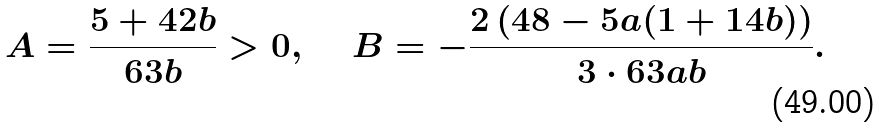Convert formula to latex. <formula><loc_0><loc_0><loc_500><loc_500>A & = \frac { 5 + 4 2 b } { 6 3 b } > 0 , & B & = - \frac { 2 \left ( 4 8 - 5 a ( 1 + 1 4 b ) \right ) } { 3 \cdot 6 3 a b } .</formula> 